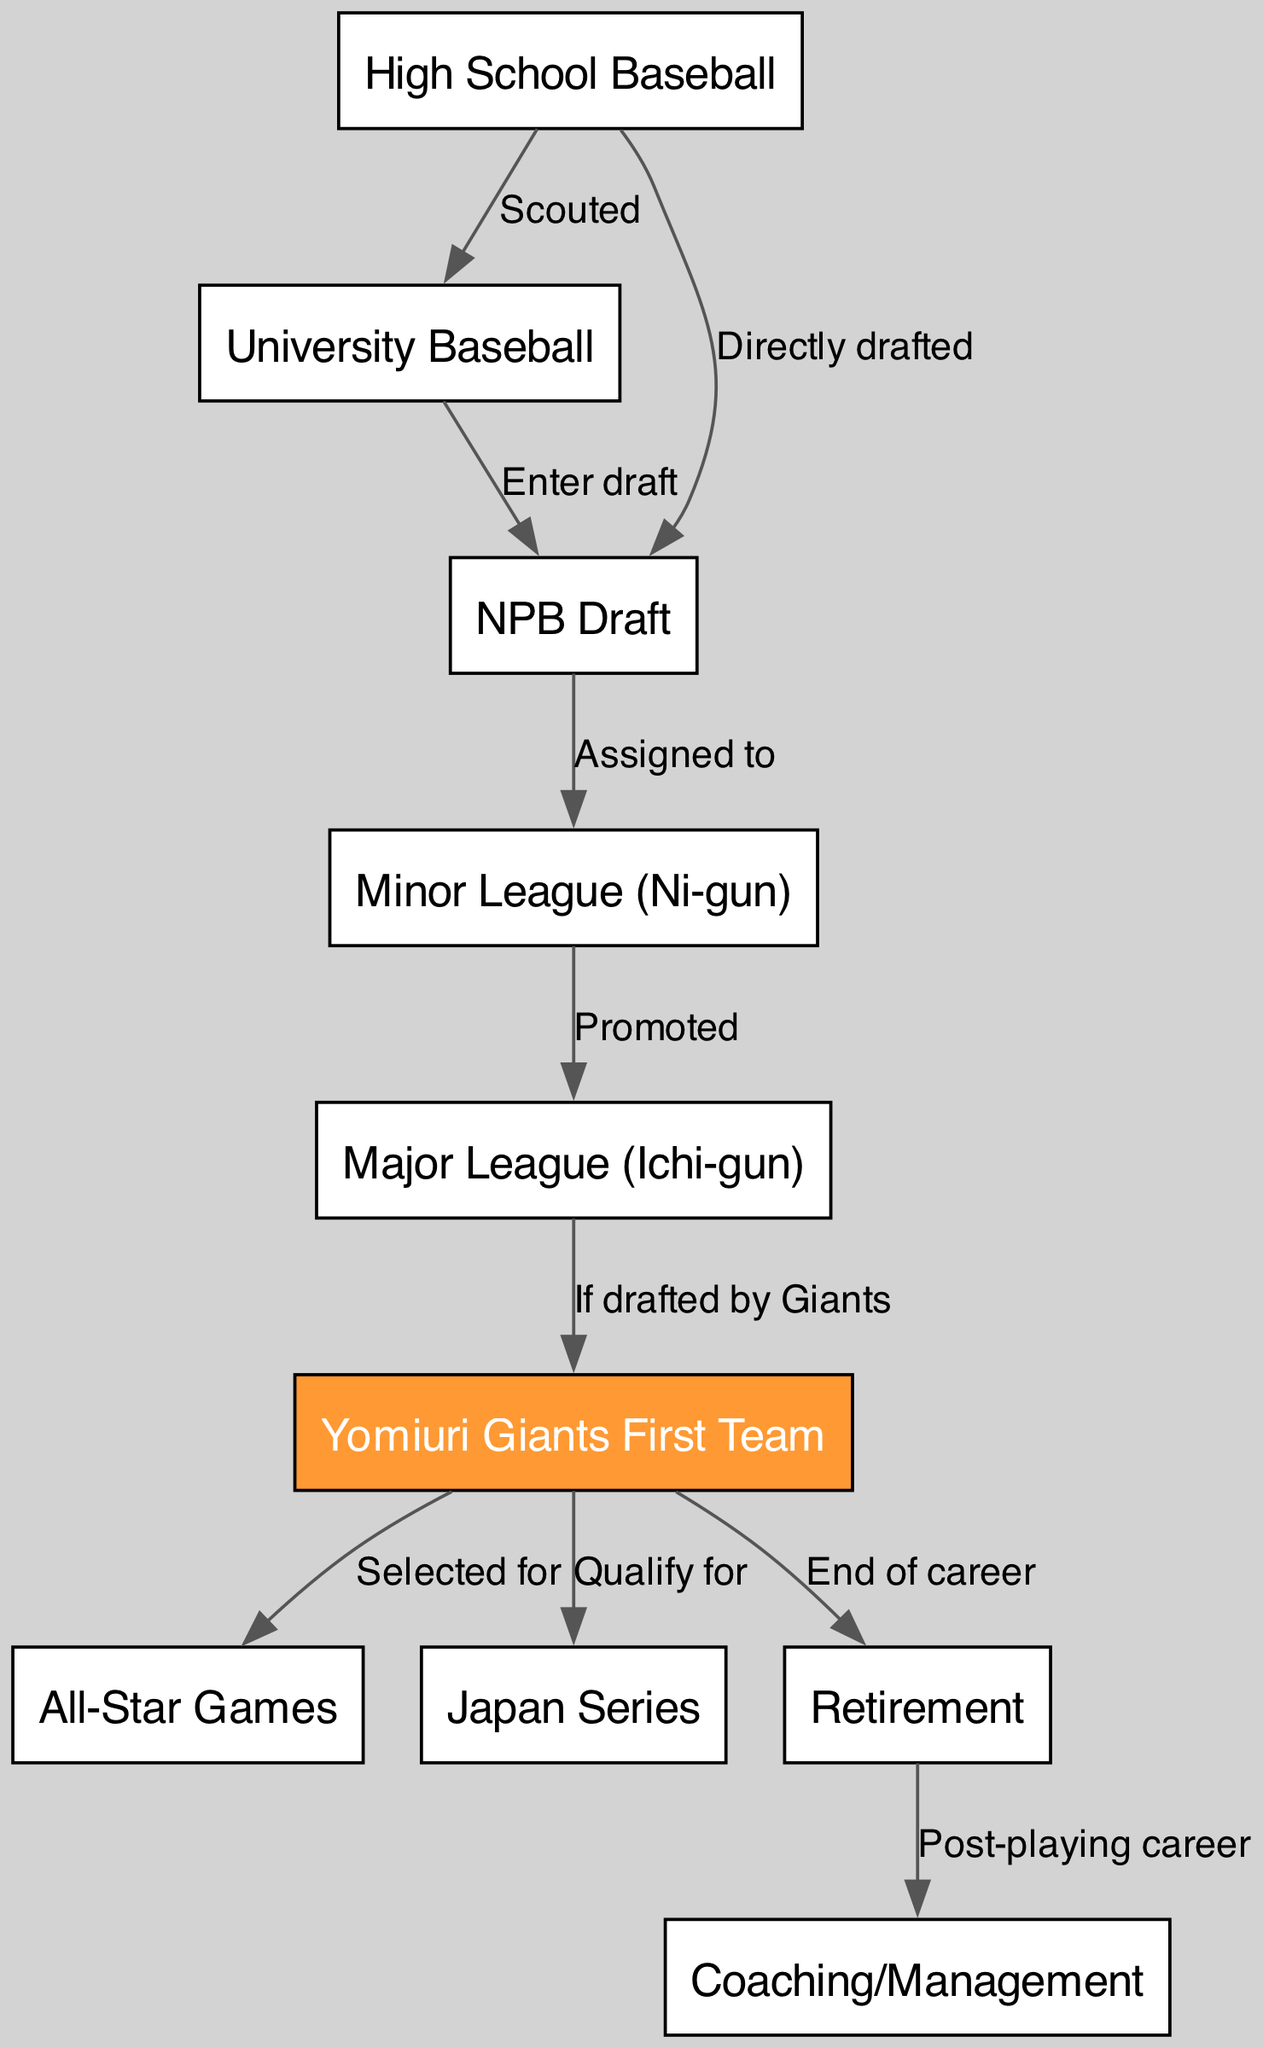What is the first stage of a professional baseball player's career? The diagram starts with "High School Baseball," which indicates that this is the initial stage of a player's career before they progress to other stages.
Answer: High School Baseball How many nodes are present in the diagram? By counting the nodes listed in the data, we have a total of 10 stages in a professional baseball player's career path, including the retirement phase.
Answer: 10 What follows "Minor League (Ni-gun)"? In the flow of the diagram, directly after "Minor League (Ni-gun)," the next step is "Major League (Ichi-gun)," which indicates promotion from the minor leagues to the major leagues.
Answer: Major League (Ichi-gun) Which node is highlighted in the diagram? The node representing "Yomiuri Giants First Team" is highlighted in orange, distinguishing it visually from the other stages and indicating it as a key focus in the player's career.
Answer: Yomiuri Giants First Team What is the relationship between "NPB Draft" and "Minor League (Ni-gun)"? The edge connecting these two nodes is labeled "Assigned to," which signifies that after being drafted, a player is assigned to a minor league team.
Answer: Assigned to Which event leads a player to the All-Star Games? If a player is on the "Yomiuri Giants First Team," they have the opportunity to be "Selected for" the All-Star Games, as indicated by the directed edge in the diagram.
Answer: Selected for What is the final career stage listed in the diagram? The diagram shows that the last stage of a professional baseball player's career is "Retirement," marking the end of their active playing career.
Answer: Retirement After retirement, what is typically the next stage for a player? Following the "Retirement" node, the diagram indicates that players often transition to "Coaching/Management," representing their continued involvement in baseball after playing.
Answer: Coaching/Management What happens to a player who is drafted but not by the Giants? The diagram does not provide any further steps for players not drafted by the Yomiuri Giants after reaching the "Major League (Ichi-gun)" node, it simply indicates their path will differ beyond that point.
Answer: N/A 